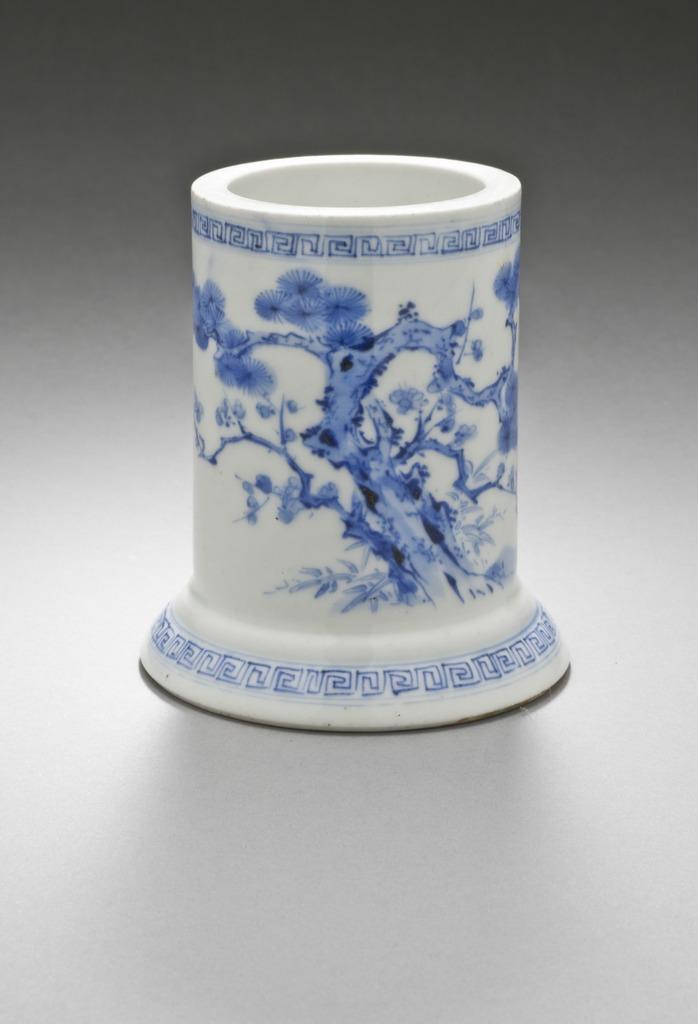In one or two sentences, can you explain what this image depicts? In this picture, we see the cylindrical brush holder with a flared base. It is in blue and white color. In the background, it is grey in color. 